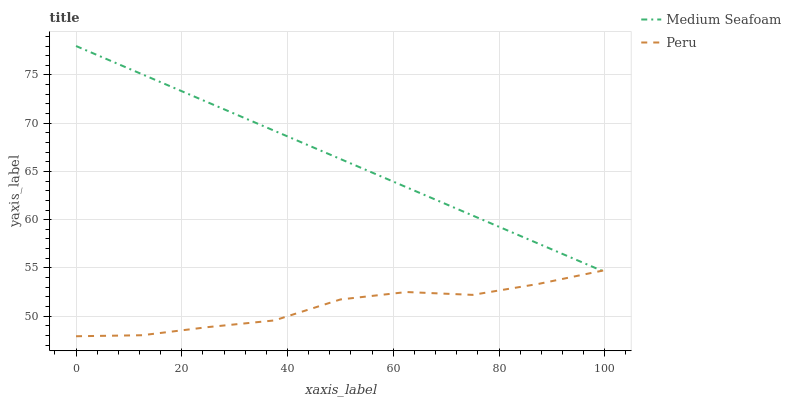Does Peru have the minimum area under the curve?
Answer yes or no. Yes. Does Medium Seafoam have the maximum area under the curve?
Answer yes or no. Yes. Does Peru have the maximum area under the curve?
Answer yes or no. No. Is Medium Seafoam the smoothest?
Answer yes or no. Yes. Is Peru the roughest?
Answer yes or no. Yes. Is Peru the smoothest?
Answer yes or no. No. Does Peru have the lowest value?
Answer yes or no. Yes. Does Medium Seafoam have the highest value?
Answer yes or no. Yes. Does Peru have the highest value?
Answer yes or no. No. Does Medium Seafoam intersect Peru?
Answer yes or no. Yes. Is Medium Seafoam less than Peru?
Answer yes or no. No. Is Medium Seafoam greater than Peru?
Answer yes or no. No. 